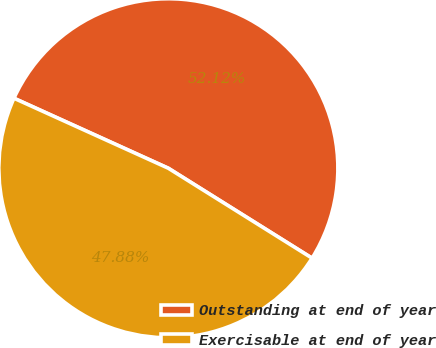Convert chart to OTSL. <chart><loc_0><loc_0><loc_500><loc_500><pie_chart><fcel>Outstanding at end of year<fcel>Exercisable at end of year<nl><fcel>52.12%<fcel>47.88%<nl></chart> 